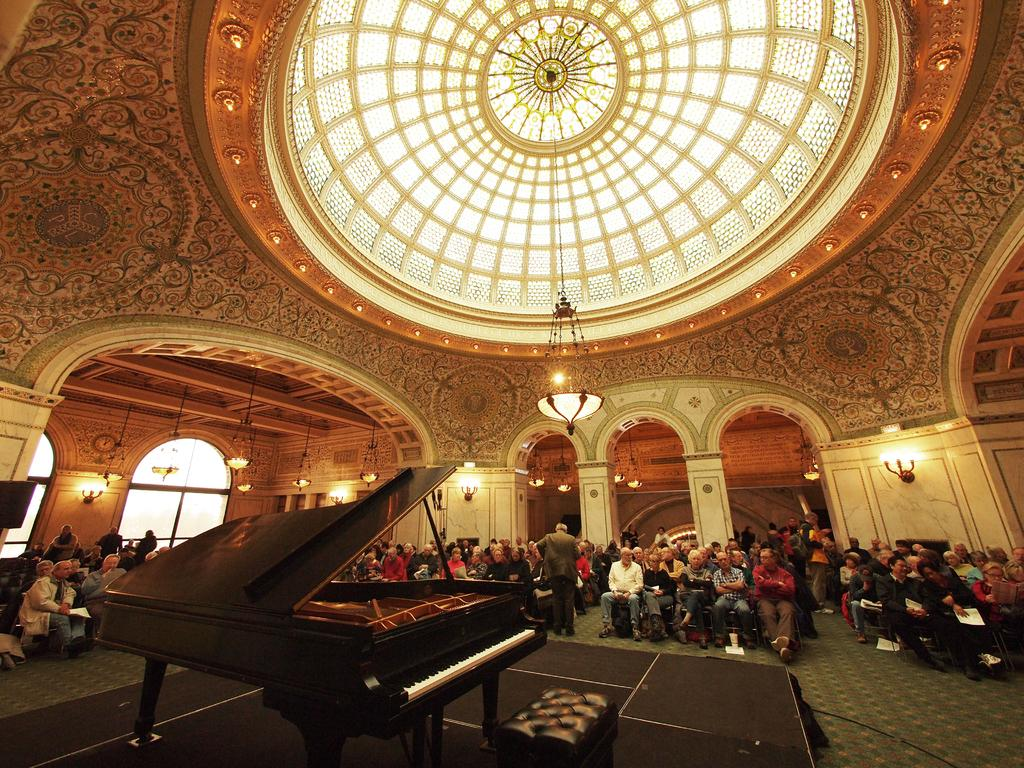What type of space is shown in the image? The image depicts a big hall. Where are the people sitting in the hall? There are people sitting on both the right and left sides of the hall. Can you describe any objects or features on the walls in the image? Yes, there is a lamp on the wall in the image. What type of carriage is parked outside the hall in the image? There is no carriage visible in the image; it only shows the interior of the hall with people sitting on both sides and a lamp on the wall. 